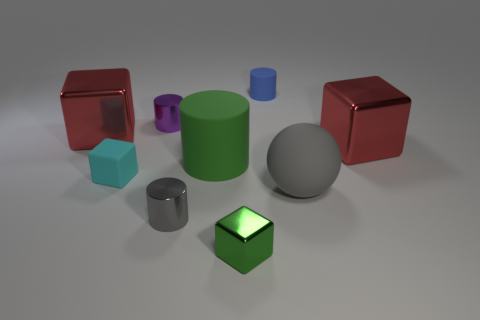Subtract 1 cylinders. How many cylinders are left? 3 Subtract all blue balls. Subtract all cyan cylinders. How many balls are left? 1 Add 1 big gray balls. How many objects exist? 10 Subtract all cylinders. How many objects are left? 5 Subtract all brown metallic things. Subtract all big red metallic things. How many objects are left? 7 Add 6 small metal objects. How many small metal objects are left? 9 Add 1 purple cylinders. How many purple cylinders exist? 2 Subtract 1 purple cylinders. How many objects are left? 8 